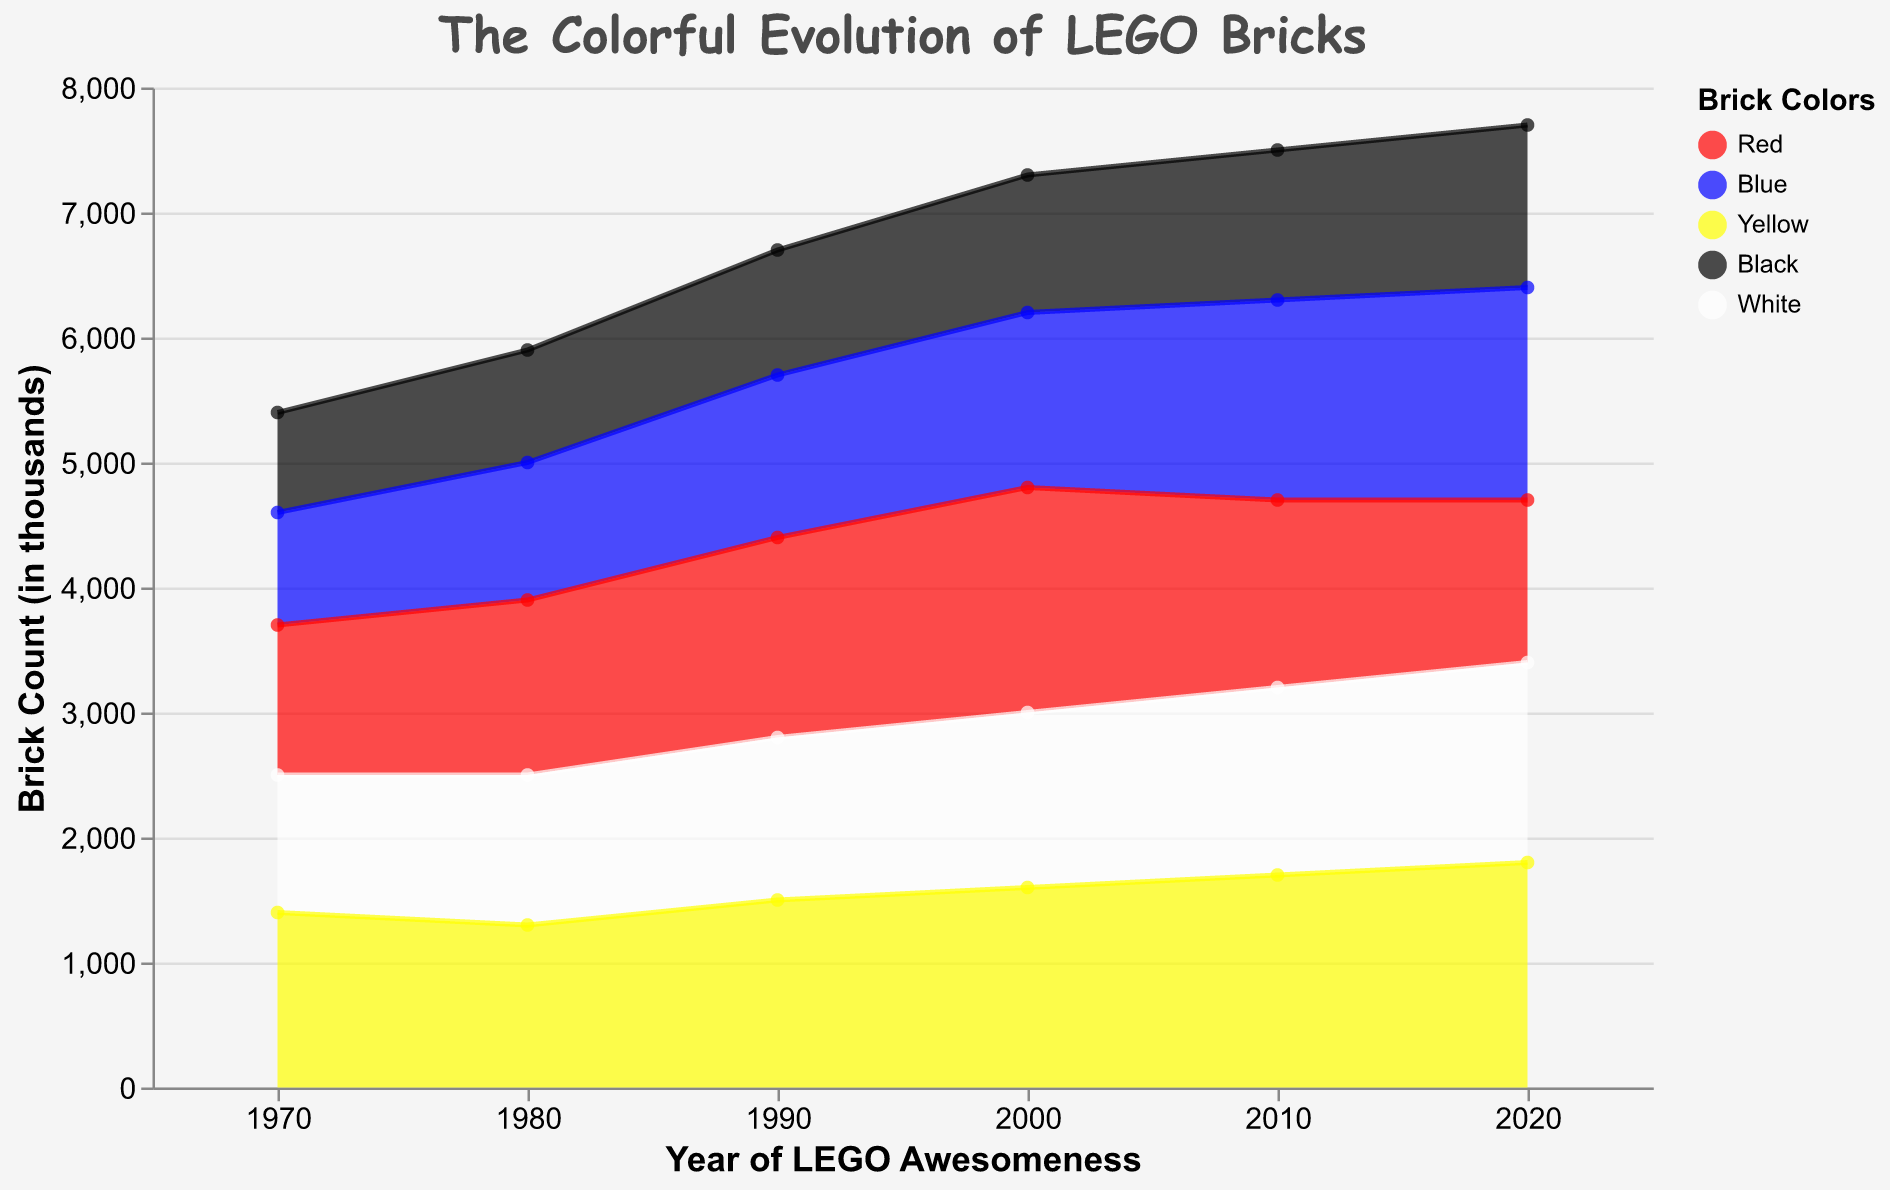What’s the trend in the number of yellow bricks from 1970 to 2020? To determine the trend, observe the counts of yellow bricks in each decade: 1400 (1970), 1300 (1980), 1500 (1990), 1600 (2000), 1700 (2010), and 1800 (2020). The counts generally increase over time.
Answer: Increasing trend Which year has the highest number of blue bricks? Compare the counts of blue bricks across all years: 900 (1970), 1100 (1980), 1300 (1990), 1400 (2000), 1600 (2010), and 1700 (2020). The highest count is in 2020.
Answer: 2020 How much did the count of red bricks change from 1970 to 1980? Subtract the count of red bricks in 1970 (1200) from the count in 1980 (1400): 1400 - 1200 = 200.
Answer: Increased by 200 Which brick color had the lowest count in 2010? Look at the counts for all colors in 2010: Red (1500), Blue (1600), Yellow (1700), Black (1200), White (1500). The lowest count is for black bricks.
Answer: Black Compare the red and yellow brick counts in 1990. Which color had more bricks and by how much? Red: 1600, Yellow: 1500. Subtract the count of yellow bricks from red bricks: 1600 - 1500 = 100.
Answer: Red by 100 In which year did black bricks see their highest count? Compare the counts of black bricks across all years: 800 (1970), 900 (1980), 1000 (1990), 1100 (2000), 1200 (2010), and 1300 (2020). The highest count is in 2020.
Answer: 2020 What’s the average count of white bricks between 2000 and 2020? Sum the counts for 2000 (1400), 2010 (1500), and 2020 (1600): 1400 + 1500 + 1600 = 4500. Divide by 3 (number of years): 4500 / 3 = 1500.
Answer: 1500 How did the counts of black bricks change from 1970 to 2020? Observe the counts of black bricks in each decade: 800 (1970), 900 (1980), 1000 (1990), 1100 (2000), 1200 (2010), 1300 (2020). The counts increased over time.
Answer: Increased Which brick color had a consistent increase in count every decade? Check each color's counts over the decades:
- Red: 1200, 1400, 1600, 1800, 1500, 1300 (decreases from 2000 to 2010)
- Blue: 900, 1100, 1300, 1400, 1600, 1700 (consistent increase)
- Yellow: 1400, 1300, 1500, 1600, 1700, 1800 (consistent increase)
- Black: 800, 900, 1000, 1100, 1200, 1300 (consistent increase)
- White: 1100, 1200, 1300, 1400, 1500, 1600 (consistent increase)
So, Blue, Yellow, Black, and White had consistent increases.
Answer: Blue, Yellow, Black, White What is the total count of bricks across all colors in 1990? Sum the counts for each color in 1990: Red (1600), Blue (1300), Yellow (1500), Black (1000), and White (1300). 1600 + 1300 + 1500 + 1000 + 1300 = 6700.
Answer: 6700 